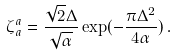<formula> <loc_0><loc_0><loc_500><loc_500>\zeta _ { a } ^ { a } = \frac { \sqrt { 2 } \Delta } { \sqrt { \alpha } } \exp ( - \frac { \pi \Delta ^ { 2 } } { 4 \alpha } ) \, .</formula> 